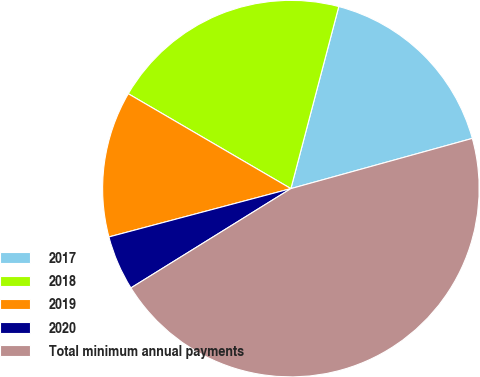<chart> <loc_0><loc_0><loc_500><loc_500><pie_chart><fcel>2017<fcel>2018<fcel>2019<fcel>2020<fcel>Total minimum annual payments<nl><fcel>16.61%<fcel>20.69%<fcel>12.54%<fcel>4.71%<fcel>45.46%<nl></chart> 